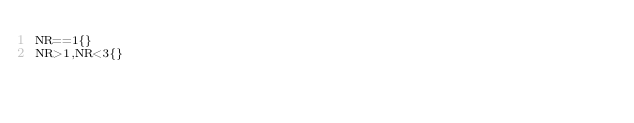<code> <loc_0><loc_0><loc_500><loc_500><_Awk_>NR==1{}
NR>1,NR<3{}
</code> 